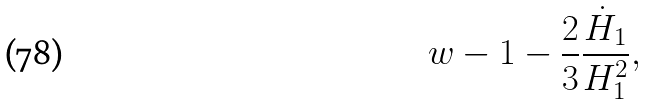Convert formula to latex. <formula><loc_0><loc_0><loc_500><loc_500>w - 1 - \frac { 2 } { 3 } \frac { \dot { H } _ { 1 } } { H _ { 1 } ^ { 2 } } ,</formula> 